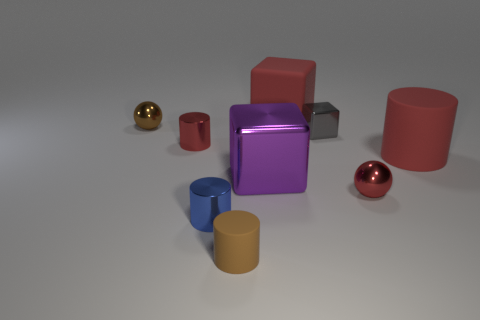The shiny thing that is the same color as the tiny rubber cylinder is what size?
Offer a very short reply. Small. There is a tiny matte thing; what shape is it?
Ensure brevity in your answer.  Cylinder. There is a gray metallic object that is the same shape as the purple object; what size is it?
Keep it short and to the point. Small. Is there anything else that has the same material as the gray object?
Make the answer very short. Yes. There is a matte cylinder left of the metal ball that is to the right of the small matte cylinder; what is its size?
Provide a short and direct response. Small. Is the number of big red objects that are on the left side of the small blue cylinder the same as the number of large red cubes?
Give a very brief answer. No. How many other things are the same color as the tiny matte cylinder?
Your response must be concise. 1. Are there fewer red metal cylinders left of the big red matte cube than large gray balls?
Your answer should be very brief. No. Are there any red rubber cylinders that have the same size as the gray object?
Offer a very short reply. No. Is the color of the big matte cube the same as the tiny ball right of the tiny brown metal object?
Your answer should be very brief. Yes. 